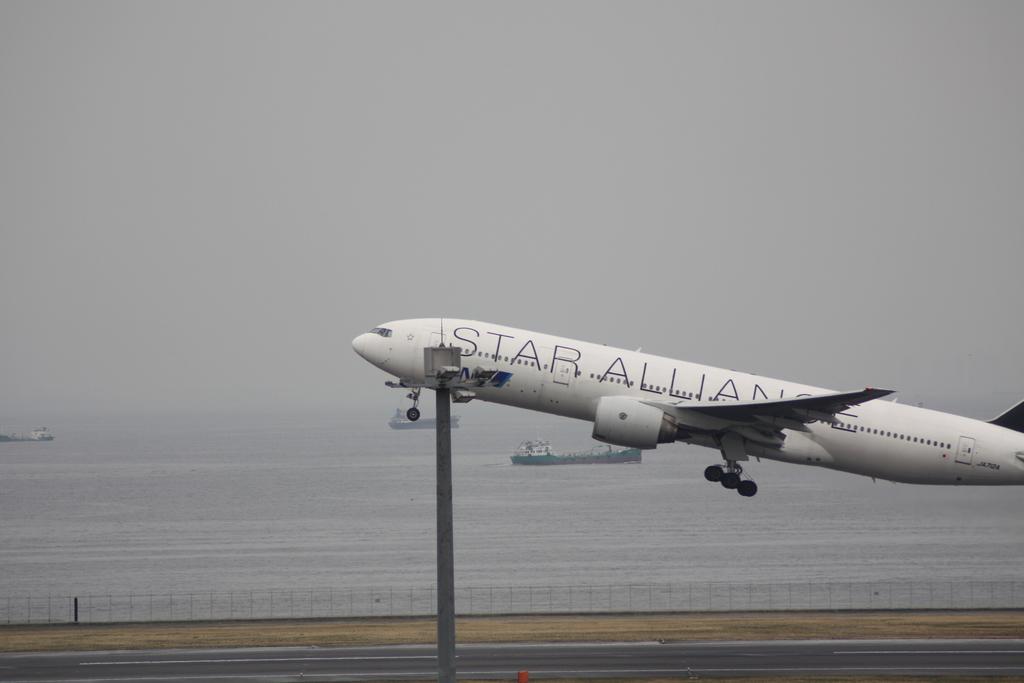What does that plane say?
Give a very brief answer. Star alliance. What is the first letter depicted on this plane?
Provide a succinct answer. S. 